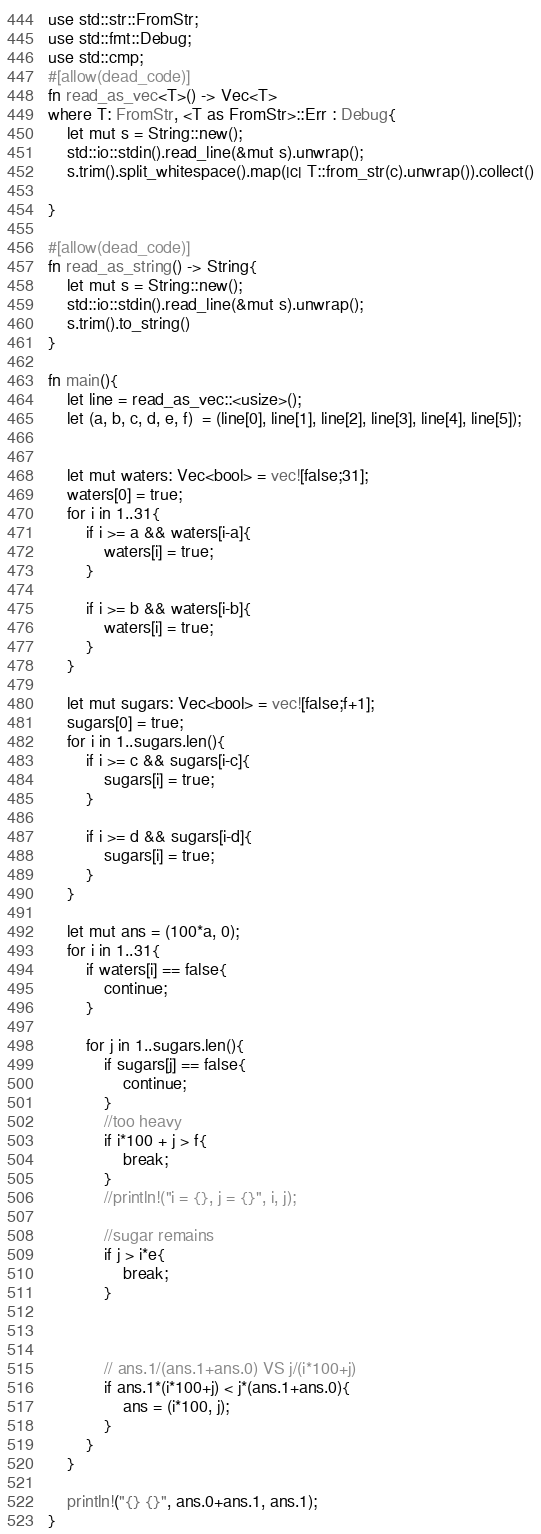<code> <loc_0><loc_0><loc_500><loc_500><_Rust_>use std::str::FromStr;
use std::fmt::Debug;
use std::cmp;
#[allow(dead_code)]
fn read_as_vec<T>() -> Vec<T>
where T: FromStr, <T as FromStr>::Err : Debug{
    let mut s = String::new();
    std::io::stdin().read_line(&mut s).unwrap();
    s.trim().split_whitespace().map(|c| T::from_str(c).unwrap()).collect()

}

#[allow(dead_code)]
fn read_as_string() -> String{
    let mut s = String::new();
    std::io::stdin().read_line(&mut s).unwrap();
    s.trim().to_string()
}

fn main(){
    let line = read_as_vec::<usize>();
    let (a, b, c, d, e, f)  = (line[0], line[1], line[2], line[3], line[4], line[5]);


    let mut waters: Vec<bool> = vec![false;31];
    waters[0] = true;
    for i in 1..31{
        if i >= a && waters[i-a]{
            waters[i] = true;
        }

        if i >= b && waters[i-b]{
            waters[i] = true;
        }
    }

    let mut sugars: Vec<bool> = vec![false;f+1];
    sugars[0] = true;
    for i in 1..sugars.len(){
        if i >= c && sugars[i-c]{
            sugars[i] = true;
        }

        if i >= d && sugars[i-d]{
            sugars[i] = true;
        }
    }

    let mut ans = (100*a, 0);
    for i in 1..31{
        if waters[i] == false{
            continue;
        }

        for j in 1..sugars.len(){
            if sugars[j] == false{
                continue;
            }
            //too heavy
            if i*100 + j > f{
                break;
            }
            //println!("i = {}, j = {}", i, j);

            //sugar remains
            if j > i*e{
                break;
            }



            // ans.1/(ans.1+ans.0) VS j/(i*100+j)
            if ans.1*(i*100+j) < j*(ans.1+ans.0){
                ans = (i*100, j);
            }
        }
    }

    println!("{} {}", ans.0+ans.1, ans.1);
}
</code> 